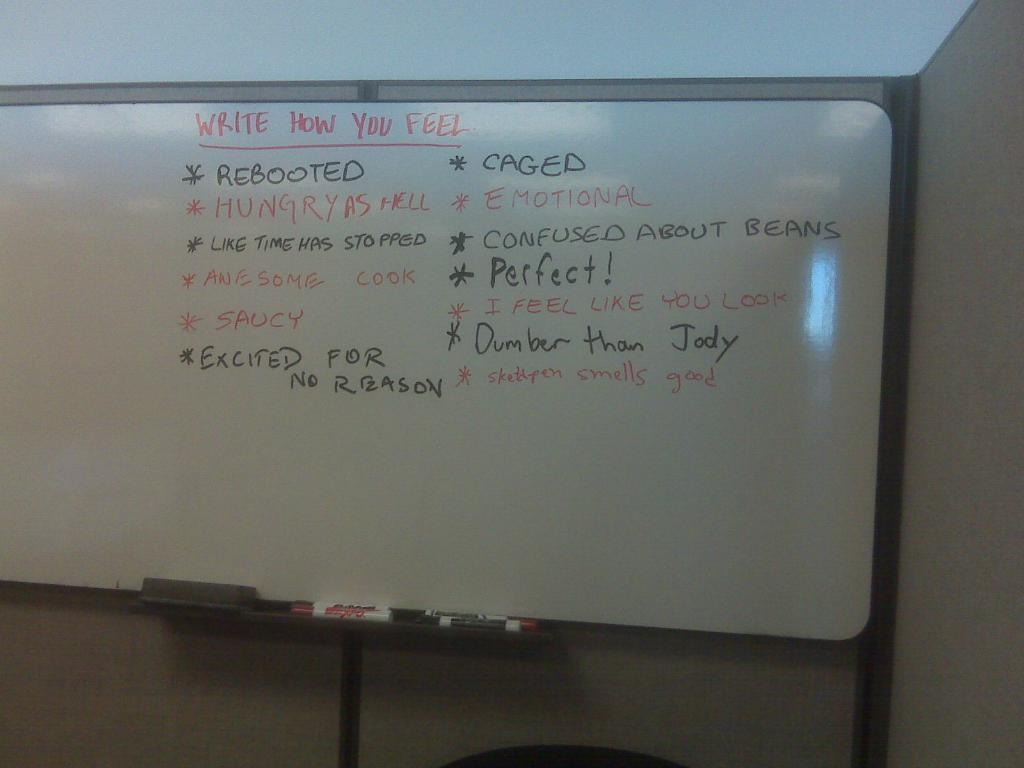<image>
Describe the image concisely. A white board with the direction; Write How You Feel, followed by some examples. 